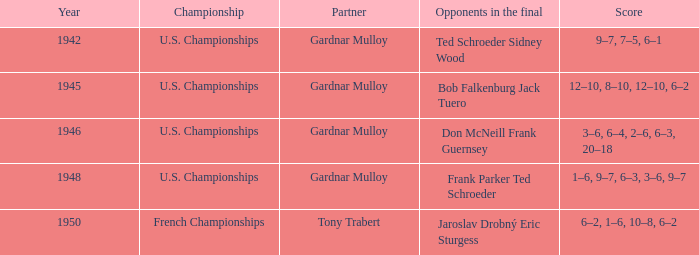Which opponents in the u.s. championships played after 1945 and had a score of 3–6, 6–4, 2–6, 6–3, 20–18? Don McNeill Frank Guernsey. 